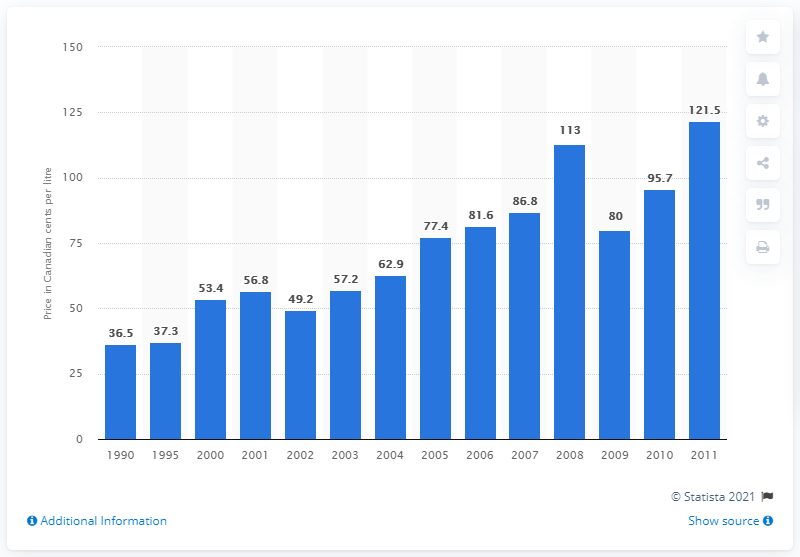Point out several critical features in this image. In 2000, the price per litre of home heating oil in Ottawa-Gatineau was 53.4 cents. 